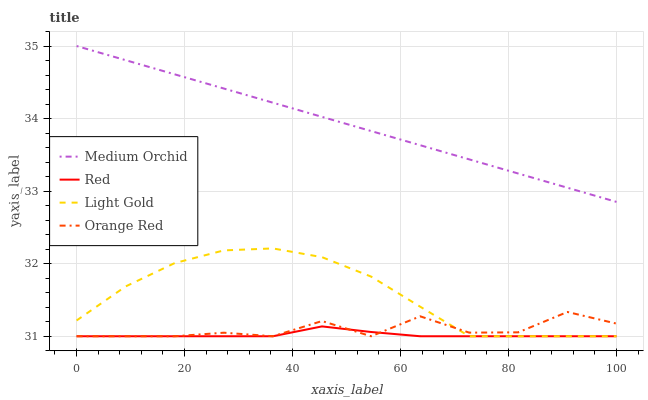Does Red have the minimum area under the curve?
Answer yes or no. Yes. Does Medium Orchid have the maximum area under the curve?
Answer yes or no. Yes. Does Light Gold have the minimum area under the curve?
Answer yes or no. No. Does Light Gold have the maximum area under the curve?
Answer yes or no. No. Is Medium Orchid the smoothest?
Answer yes or no. Yes. Is Orange Red the roughest?
Answer yes or no. Yes. Is Light Gold the smoothest?
Answer yes or no. No. Is Light Gold the roughest?
Answer yes or no. No. Does Light Gold have the highest value?
Answer yes or no. No. Is Light Gold less than Medium Orchid?
Answer yes or no. Yes. Is Medium Orchid greater than Light Gold?
Answer yes or no. Yes. Does Light Gold intersect Medium Orchid?
Answer yes or no. No. 